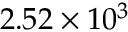<formula> <loc_0><loc_0><loc_500><loc_500>2 . 5 2 \times 1 0 ^ { 3 }</formula> 